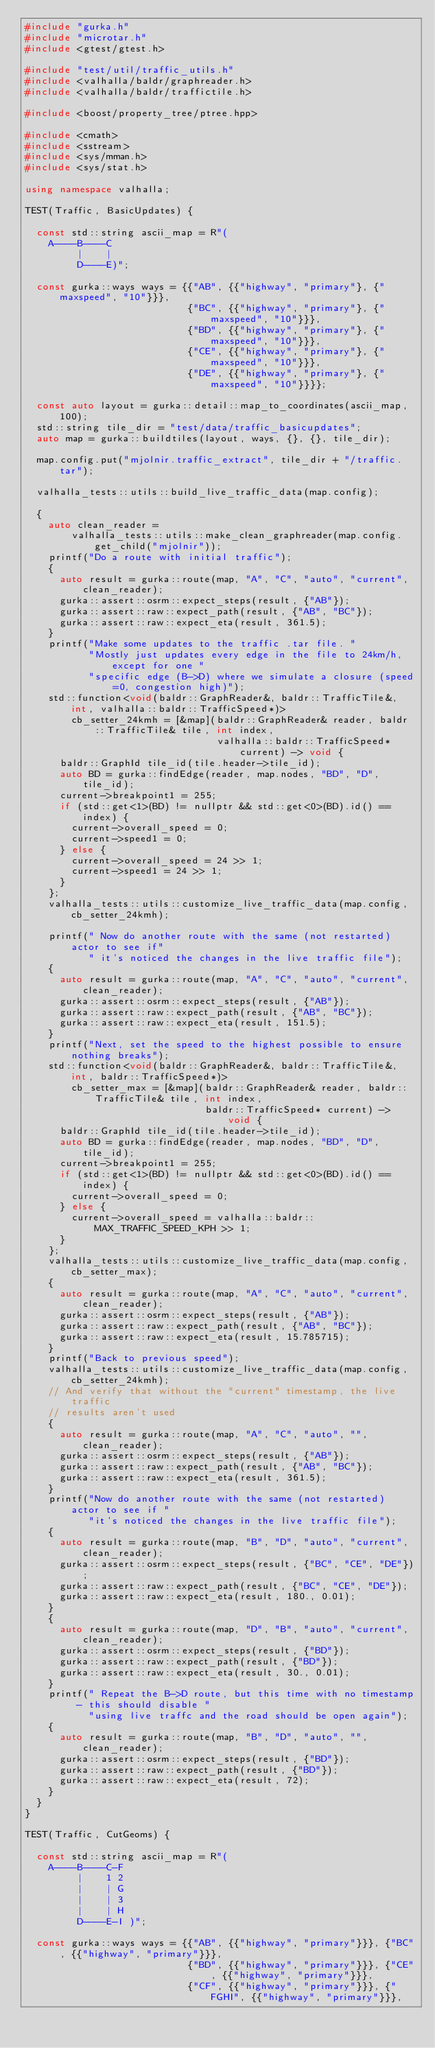Convert code to text. <code><loc_0><loc_0><loc_500><loc_500><_C++_>#include "gurka.h"
#include "microtar.h"
#include <gtest/gtest.h>

#include "test/util/traffic_utils.h"
#include <valhalla/baldr/graphreader.h>
#include <valhalla/baldr/traffictile.h>

#include <boost/property_tree/ptree.hpp>

#include <cmath>
#include <sstream>
#include <sys/mman.h>
#include <sys/stat.h>

using namespace valhalla;

TEST(Traffic, BasicUpdates) {

  const std::string ascii_map = R"(
    A----B----C
         |    |
         D----E)";

  const gurka::ways ways = {{"AB", {{"highway", "primary"}, {"maxspeed", "10"}}},
                            {"BC", {{"highway", "primary"}, {"maxspeed", "10"}}},
                            {"BD", {{"highway", "primary"}, {"maxspeed", "10"}}},
                            {"CE", {{"highway", "primary"}, {"maxspeed", "10"}}},
                            {"DE", {{"highway", "primary"}, {"maxspeed", "10"}}}};

  const auto layout = gurka::detail::map_to_coordinates(ascii_map, 100);
  std::string tile_dir = "test/data/traffic_basicupdates";
  auto map = gurka::buildtiles(layout, ways, {}, {}, tile_dir);

  map.config.put("mjolnir.traffic_extract", tile_dir + "/traffic.tar");

  valhalla_tests::utils::build_live_traffic_data(map.config);

  {
    auto clean_reader =
        valhalla_tests::utils::make_clean_graphreader(map.config.get_child("mjolnir"));
    printf("Do a route with initial traffic");
    {
      auto result = gurka::route(map, "A", "C", "auto", "current", clean_reader);
      gurka::assert::osrm::expect_steps(result, {"AB"});
      gurka::assert::raw::expect_path(result, {"AB", "BC"});
      gurka::assert::raw::expect_eta(result, 361.5);
    }
    printf("Make some updates to the traffic .tar file. "
           "Mostly just updates every edge in the file to 24km/h, except for one "
           "specific edge (B->D) where we simulate a closure (speed=0, congestion high)");
    std::function<void(baldr::GraphReader&, baldr::TrafficTile&, int, valhalla::baldr::TrafficSpeed*)>
        cb_setter_24kmh = [&map](baldr::GraphReader& reader, baldr::TrafficTile& tile, int index,
                                 valhalla::baldr::TrafficSpeed* current) -> void {
      baldr::GraphId tile_id(tile.header->tile_id);
      auto BD = gurka::findEdge(reader, map.nodes, "BD", "D", tile_id);
      current->breakpoint1 = 255;
      if (std::get<1>(BD) != nullptr && std::get<0>(BD).id() == index) {
        current->overall_speed = 0;
        current->speed1 = 0;
      } else {
        current->overall_speed = 24 >> 1;
        current->speed1 = 24 >> 1;
      }
    };
    valhalla_tests::utils::customize_live_traffic_data(map.config, cb_setter_24kmh);

    printf(" Now do another route with the same (not restarted) actor to see if"
           " it's noticed the changes in the live traffic file");
    {
      auto result = gurka::route(map, "A", "C", "auto", "current", clean_reader);
      gurka::assert::osrm::expect_steps(result, {"AB"});
      gurka::assert::raw::expect_path(result, {"AB", "BC"});
      gurka::assert::raw::expect_eta(result, 151.5);
    }
    printf("Next, set the speed to the highest possible to ensure nothing breaks");
    std::function<void(baldr::GraphReader&, baldr::TrafficTile&, int, baldr::TrafficSpeed*)>
        cb_setter_max = [&map](baldr::GraphReader& reader, baldr::TrafficTile& tile, int index,
                               baldr::TrafficSpeed* current) -> void {
      baldr::GraphId tile_id(tile.header->tile_id);
      auto BD = gurka::findEdge(reader, map.nodes, "BD", "D", tile_id);
      current->breakpoint1 = 255;
      if (std::get<1>(BD) != nullptr && std::get<0>(BD).id() == index) {
        current->overall_speed = 0;
      } else {
        current->overall_speed = valhalla::baldr::MAX_TRAFFIC_SPEED_KPH >> 1;
      }
    };
    valhalla_tests::utils::customize_live_traffic_data(map.config, cb_setter_max);
    {
      auto result = gurka::route(map, "A", "C", "auto", "current", clean_reader);
      gurka::assert::osrm::expect_steps(result, {"AB"});
      gurka::assert::raw::expect_path(result, {"AB", "BC"});
      gurka::assert::raw::expect_eta(result, 15.785715);
    }
    printf("Back to previous speed");
    valhalla_tests::utils::customize_live_traffic_data(map.config, cb_setter_24kmh);
    // And verify that without the "current" timestamp, the live traffic
    // results aren't used
    {
      auto result = gurka::route(map, "A", "C", "auto", "", clean_reader);
      gurka::assert::osrm::expect_steps(result, {"AB"});
      gurka::assert::raw::expect_path(result, {"AB", "BC"});
      gurka::assert::raw::expect_eta(result, 361.5);
    }
    printf("Now do another route with the same (not restarted) actor to see if "
           "it's noticed the changes in the live traffic file");
    {
      auto result = gurka::route(map, "B", "D", "auto", "current", clean_reader);
      gurka::assert::osrm::expect_steps(result, {"BC", "CE", "DE"});
      gurka::assert::raw::expect_path(result, {"BC", "CE", "DE"});
      gurka::assert::raw::expect_eta(result, 180., 0.01);
    }
    {
      auto result = gurka::route(map, "D", "B", "auto", "current", clean_reader);
      gurka::assert::osrm::expect_steps(result, {"BD"});
      gurka::assert::raw::expect_path(result, {"BD"});
      gurka::assert::raw::expect_eta(result, 30., 0.01);
    }
    printf(" Repeat the B->D route, but this time with no timestamp - this should disable "
           "using live traffc and the road should be open again");
    {
      auto result = gurka::route(map, "B", "D", "auto", "", clean_reader);
      gurka::assert::osrm::expect_steps(result, {"BD"});
      gurka::assert::raw::expect_path(result, {"BD"});
      gurka::assert::raw::expect_eta(result, 72);
    }
  }
}

TEST(Traffic, CutGeoms) {

  const std::string ascii_map = R"(
    A----B----C-F
         |    1 2
         |    | G
         |    | 3
         |    | H
         D----E-I )";

  const gurka::ways ways = {{"AB", {{"highway", "primary"}}}, {"BC", {{"highway", "primary"}}},
                            {"BD", {{"highway", "primary"}}}, {"CE", {{"highway", "primary"}}},
                            {"CF", {{"highway", "primary"}}}, {"FGHI", {{"highway", "primary"}}},</code> 